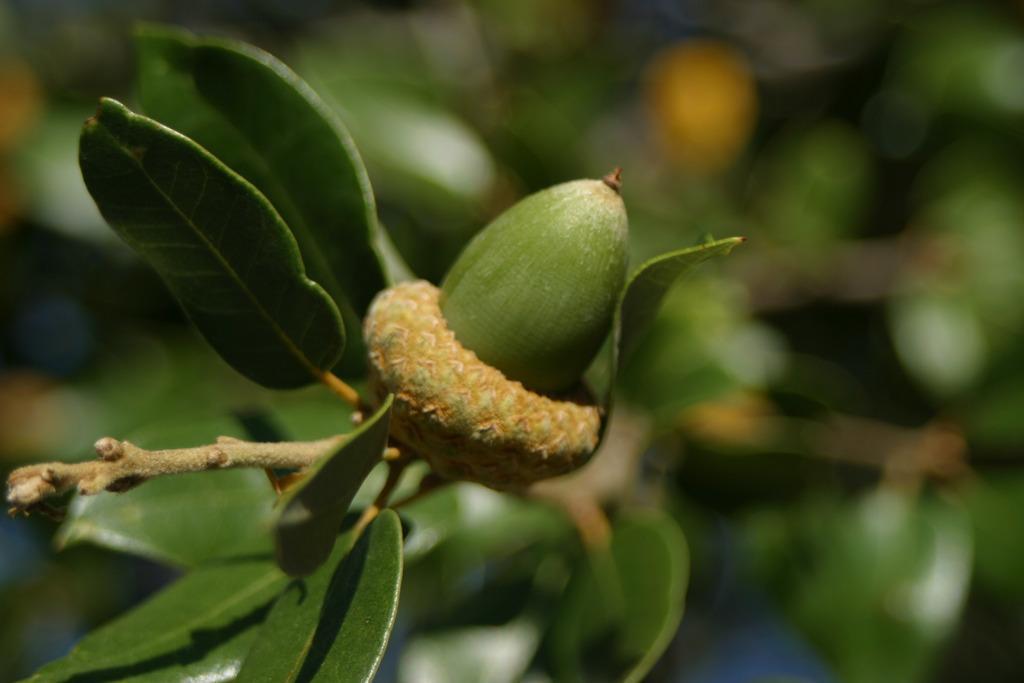Describe this image in one or two sentences. This image consists of plants. In the front, it looks like a fruit. And the background is blurred. And we can see the green leaves. 